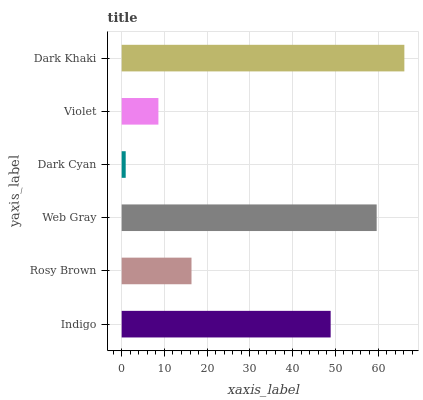Is Dark Cyan the minimum?
Answer yes or no. Yes. Is Dark Khaki the maximum?
Answer yes or no. Yes. Is Rosy Brown the minimum?
Answer yes or no. No. Is Rosy Brown the maximum?
Answer yes or no. No. Is Indigo greater than Rosy Brown?
Answer yes or no. Yes. Is Rosy Brown less than Indigo?
Answer yes or no. Yes. Is Rosy Brown greater than Indigo?
Answer yes or no. No. Is Indigo less than Rosy Brown?
Answer yes or no. No. Is Indigo the high median?
Answer yes or no. Yes. Is Rosy Brown the low median?
Answer yes or no. Yes. Is Violet the high median?
Answer yes or no. No. Is Indigo the low median?
Answer yes or no. No. 